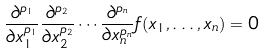<formula> <loc_0><loc_0><loc_500><loc_500>\frac { \partial ^ { p _ { 1 } } } { \partial x _ { 1 } ^ { p _ { 1 } } } \frac { \partial ^ { p _ { 2 } } } { \partial x _ { 2 } ^ { p _ { 2 } } } \cdots \frac { \partial ^ { p _ { n } } } { \partial x _ { n } ^ { p _ { n } } } f ( x _ { 1 } , \dots , x _ { n } ) = 0</formula> 